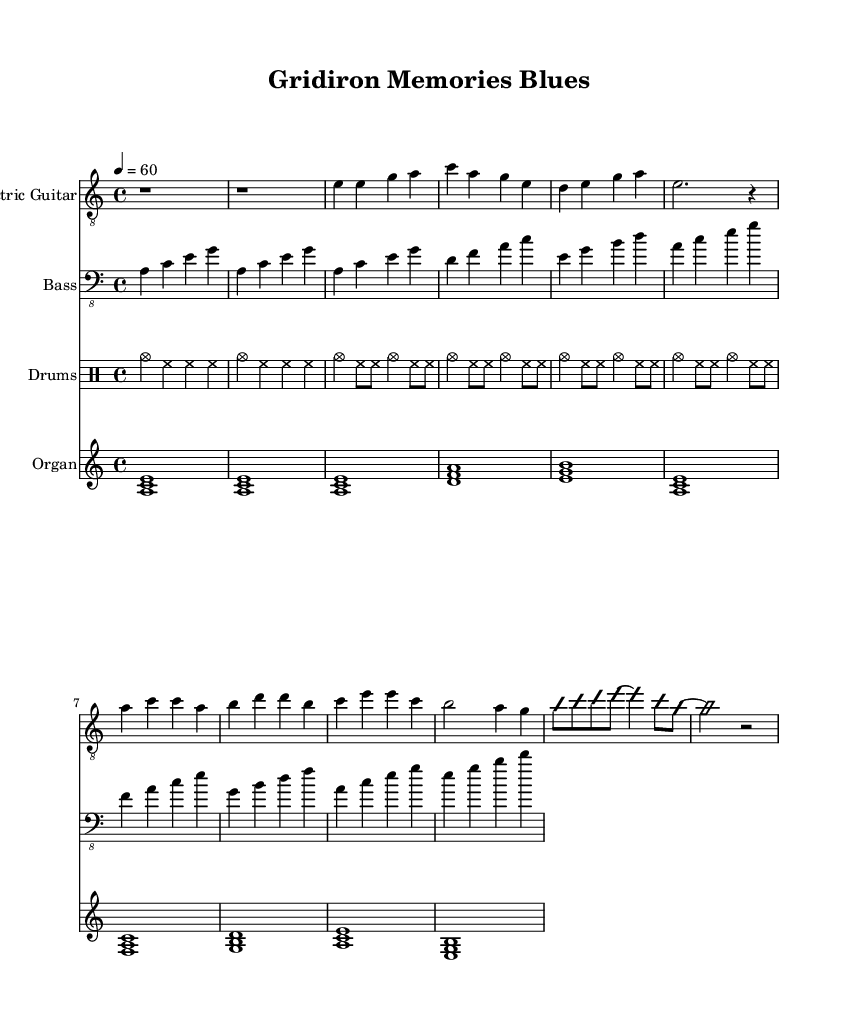What is the key signature of this music? The key signature is A minor, indicated by the lack of sharps or flats in the key signature part of the sheet music.
Answer: A minor What is the time signature of this music? The time signature is 4/4, shown at the beginning of the music notation, indicating four beats per measure and a quarter note gets one beat.
Answer: 4/4 What is the tempo marking for this piece? The tempo is indicated as quarter note equals 60, which suggests the piece should be played at 60 beats per minute.
Answer: 60 How many measures are in the intro section? The intro consists of two measures, which can be counted by identifying the bar lines that delineate the sections of the music.
Answer: 2 What instruments are included in this score? The instruments listed in the score are Electric Guitar, Bass, Drums, and Organ, each represented by a separate staff.
Answer: Electric Guitar, Bass, Drums, Organ What is the chord progression in the verse section? The chord progression seen in the verse section is E minor, D major, A major, indicating how the harmonic structure develops throughout the verse.
Answer: E minor, D major, A major Does the music include a guitar solo section? Yes, there is a designated section for guitar solo, indicated by the notation "improvisationOn," suggesting that the guitar player can improvise during this part.
Answer: Yes 